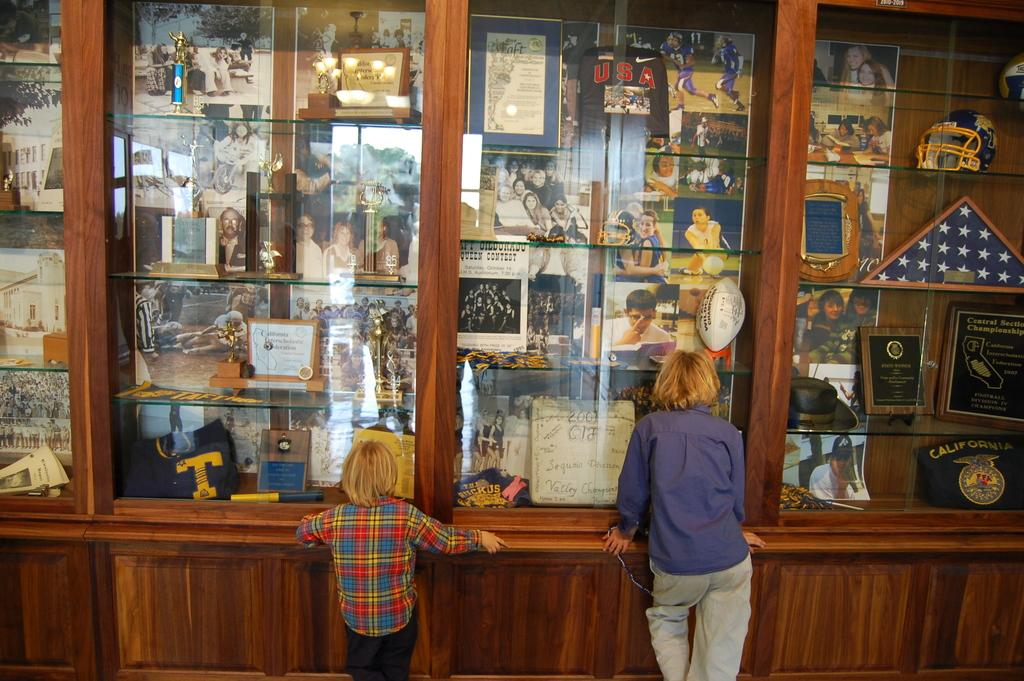What type of storage units are visible in the image? There are shelves in the image. What is placed on the shelves? There are frames and cups on the shelves. Can you describe the people in the image? There are two kids at the bottom of the image. What type of rod can be seen connecting the shelves in the image? There is no rod connecting the shelves in the image; the shelves are separate units. 